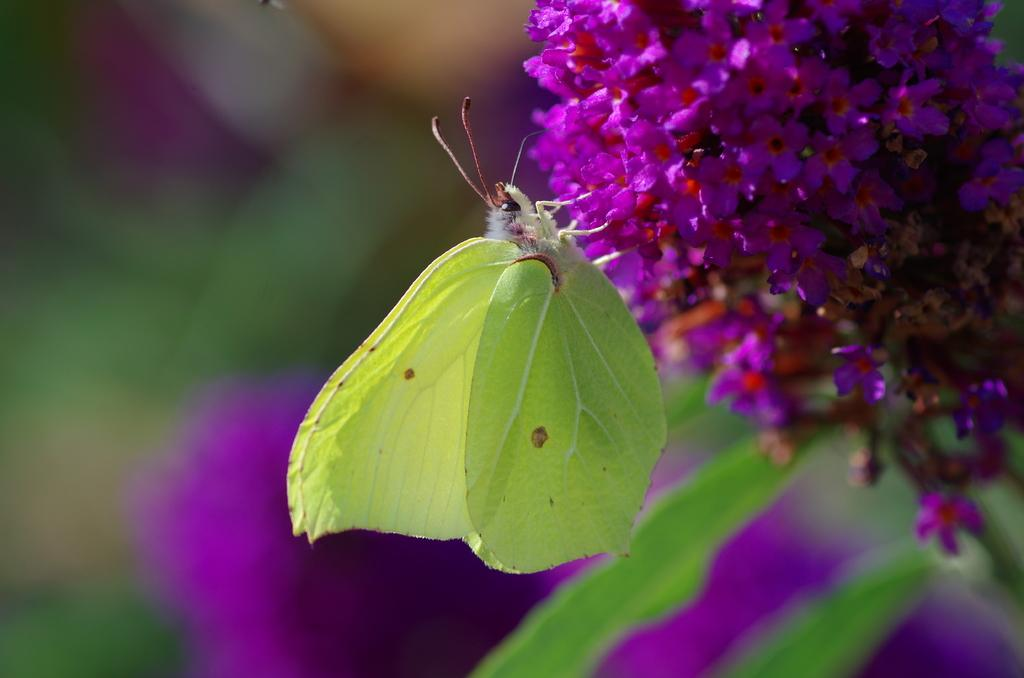What insect is present in the image? There is a green fly in the image. What is the fly doing in the image? The fly is on flowers. Can you describe the background of the image? The background of the image is blurry. How many pies does the fly attempt to disgust in the image? There are no pies present in the image, and the fly is not attempting to disgust anything. 